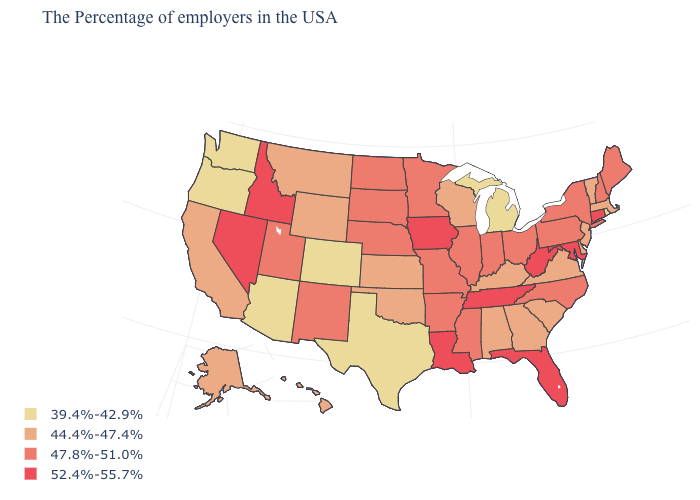What is the lowest value in the USA?
Short answer required. 39.4%-42.9%. Is the legend a continuous bar?
Write a very short answer. No. Among the states that border Kansas , which have the highest value?
Give a very brief answer. Missouri, Nebraska. How many symbols are there in the legend?
Give a very brief answer. 4. What is the highest value in the USA?
Quick response, please. 52.4%-55.7%. Among the states that border Arizona , does New Mexico have the lowest value?
Answer briefly. No. Name the states that have a value in the range 39.4%-42.9%?
Quick response, please. Rhode Island, Michigan, Texas, Colorado, Arizona, Washington, Oregon. Name the states that have a value in the range 44.4%-47.4%?
Short answer required. Massachusetts, Vermont, New Jersey, Delaware, Virginia, South Carolina, Georgia, Kentucky, Alabama, Wisconsin, Kansas, Oklahoma, Wyoming, Montana, California, Alaska, Hawaii. What is the lowest value in the South?
Be succinct. 39.4%-42.9%. Name the states that have a value in the range 39.4%-42.9%?
Quick response, please. Rhode Island, Michigan, Texas, Colorado, Arizona, Washington, Oregon. Does New Mexico have a lower value than West Virginia?
Answer briefly. Yes. Which states have the lowest value in the USA?
Give a very brief answer. Rhode Island, Michigan, Texas, Colorado, Arizona, Washington, Oregon. What is the value of Missouri?
Give a very brief answer. 47.8%-51.0%. What is the highest value in states that border Ohio?
Give a very brief answer. 52.4%-55.7%. 